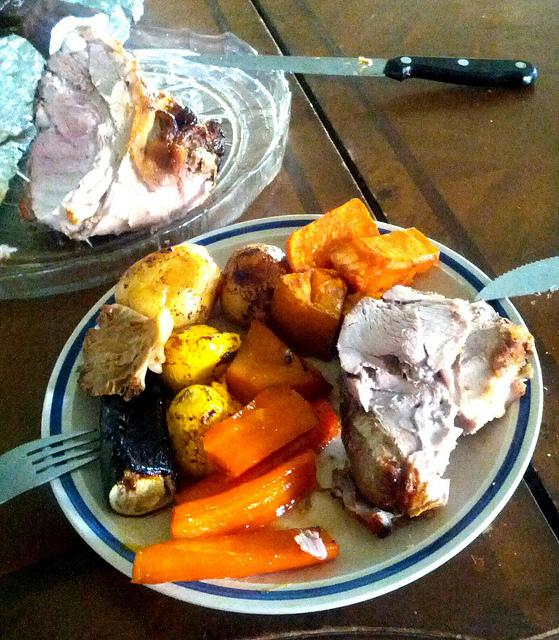How have these vegetables been cooked? Please explain your reasoning. roasted. The meal looks like a potroast with veggies cooked in it. 